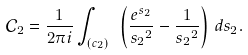<formula> <loc_0><loc_0><loc_500><loc_500>\mathcal { C } _ { 2 } = \frac { 1 } { 2 \pi i } \int _ { ( c _ { 2 } ) \ } \left ( \frac { e ^ { s _ { 2 } } } { { s _ { 2 } } ^ { 2 } } - \frac { 1 } { { s _ { 2 } } ^ { 2 } } \right ) \, d s _ { 2 } .</formula> 